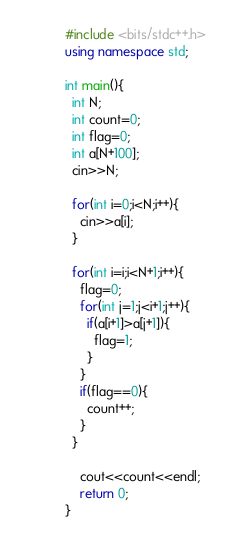Convert code to text. <code><loc_0><loc_0><loc_500><loc_500><_C++_>#include <bits/stdc++.h>
using namespace std;

int main(){
  int N;
  int count=0;
  int flag=0;
  int a[N+100];
  cin>>N;
  
  for(int i=0;i<N;i++){
    cin>>a[i];
  }
  
  for(int i=i;i<N+1;i++){
    flag=0;
    for(int j=1;j<i+1;j++){
      if(a[i+1]>a[j+1]){
        flag=1;
      }
    }
    if(flag==0){
      count++;
    }
  }
  
    cout<<count<<endl;
    return 0;
}</code> 